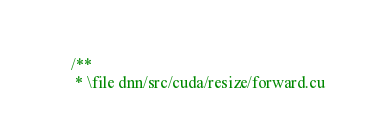<code> <loc_0><loc_0><loc_500><loc_500><_Cuda_>/**
 * \file dnn/src/cuda/resize/forward.cu</code> 